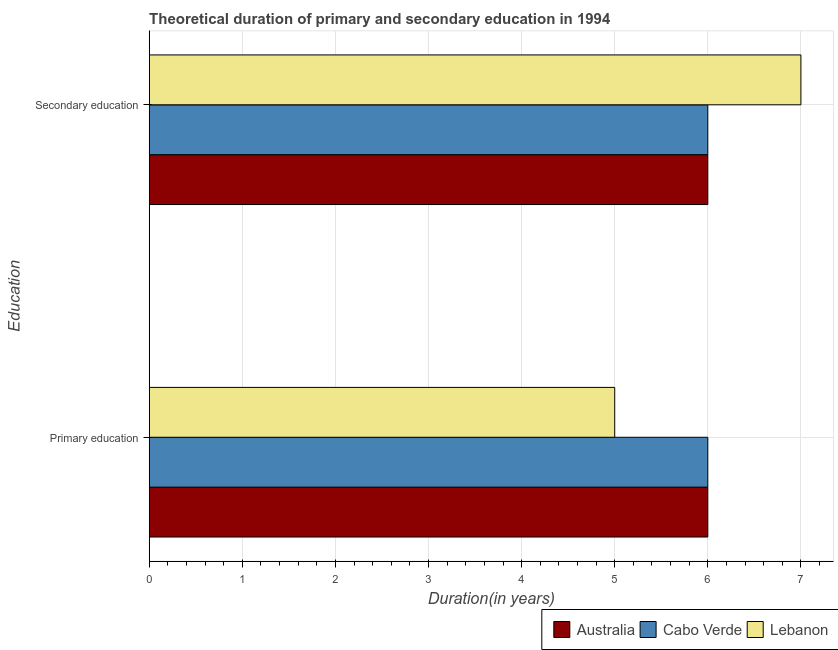How many different coloured bars are there?
Give a very brief answer. 3. How many groups of bars are there?
Your response must be concise. 2. Are the number of bars per tick equal to the number of legend labels?
Give a very brief answer. Yes. Are the number of bars on each tick of the Y-axis equal?
Your answer should be compact. Yes. How many bars are there on the 2nd tick from the top?
Keep it short and to the point. 3. How many bars are there on the 1st tick from the bottom?
Give a very brief answer. 3. What is the label of the 1st group of bars from the top?
Make the answer very short. Secondary education. What is the duration of secondary education in Australia?
Your answer should be compact. 6. Across all countries, what is the maximum duration of secondary education?
Provide a short and direct response. 7. In which country was the duration of secondary education maximum?
Offer a terse response. Lebanon. In which country was the duration of primary education minimum?
Ensure brevity in your answer.  Lebanon. What is the total duration of primary education in the graph?
Provide a succinct answer. 17. What is the difference between the duration of secondary education in Lebanon and that in Cabo Verde?
Ensure brevity in your answer.  1. What is the difference between the duration of primary education in Lebanon and the duration of secondary education in Australia?
Make the answer very short. -1. What is the average duration of primary education per country?
Offer a very short reply. 5.67. What is the difference between the duration of primary education and duration of secondary education in Cabo Verde?
Keep it short and to the point. 0. In how many countries, is the duration of primary education greater than 0.6000000000000001 years?
Offer a very short reply. 3. What is the ratio of the duration of primary education in Cabo Verde to that in Australia?
Your response must be concise. 1. Is the duration of primary education in Lebanon less than that in Australia?
Offer a terse response. Yes. In how many countries, is the duration of secondary education greater than the average duration of secondary education taken over all countries?
Give a very brief answer. 1. What does the 2nd bar from the top in Primary education represents?
Your response must be concise. Cabo Verde. How many bars are there?
Make the answer very short. 6. Does the graph contain any zero values?
Make the answer very short. No. Where does the legend appear in the graph?
Give a very brief answer. Bottom right. What is the title of the graph?
Offer a very short reply. Theoretical duration of primary and secondary education in 1994. What is the label or title of the X-axis?
Give a very brief answer. Duration(in years). What is the label or title of the Y-axis?
Your answer should be very brief. Education. What is the Duration(in years) in Australia in Primary education?
Give a very brief answer. 6. What is the Duration(in years) of Cabo Verde in Secondary education?
Give a very brief answer. 6. What is the Duration(in years) of Lebanon in Secondary education?
Offer a very short reply. 7. Across all Education, what is the maximum Duration(in years) in Cabo Verde?
Give a very brief answer. 6. Across all Education, what is the maximum Duration(in years) of Lebanon?
Provide a short and direct response. 7. Across all Education, what is the minimum Duration(in years) in Australia?
Keep it short and to the point. 6. Across all Education, what is the minimum Duration(in years) in Cabo Verde?
Offer a very short reply. 6. What is the total Duration(in years) in Cabo Verde in the graph?
Provide a succinct answer. 12. What is the total Duration(in years) of Lebanon in the graph?
Provide a short and direct response. 12. What is the difference between the Duration(in years) of Cabo Verde in Primary education and that in Secondary education?
Your answer should be compact. 0. What is the difference between the Duration(in years) in Lebanon in Primary education and that in Secondary education?
Provide a short and direct response. -2. What is the difference between the Duration(in years) of Australia in Primary education and the Duration(in years) of Cabo Verde in Secondary education?
Offer a terse response. 0. What is the difference between the Duration(in years) in Australia in Primary education and the Duration(in years) in Lebanon in Secondary education?
Provide a short and direct response. -1. What is the difference between the Duration(in years) in Cabo Verde in Primary education and the Duration(in years) in Lebanon in Secondary education?
Keep it short and to the point. -1. What is the average Duration(in years) in Australia per Education?
Make the answer very short. 6. What is the difference between the Duration(in years) of Australia and Duration(in years) of Cabo Verde in Primary education?
Provide a short and direct response. 0. What is the difference between the Duration(in years) of Cabo Verde and Duration(in years) of Lebanon in Primary education?
Make the answer very short. 1. What is the difference between the Duration(in years) in Australia and Duration(in years) in Cabo Verde in Secondary education?
Offer a terse response. 0. What is the difference between the Duration(in years) of Australia and Duration(in years) of Lebanon in Secondary education?
Offer a very short reply. -1. What is the difference between the Duration(in years) in Cabo Verde and Duration(in years) in Lebanon in Secondary education?
Provide a succinct answer. -1. What is the difference between the highest and the second highest Duration(in years) in Australia?
Offer a very short reply. 0. What is the difference between the highest and the second highest Duration(in years) of Lebanon?
Give a very brief answer. 2. What is the difference between the highest and the lowest Duration(in years) of Lebanon?
Ensure brevity in your answer.  2. 